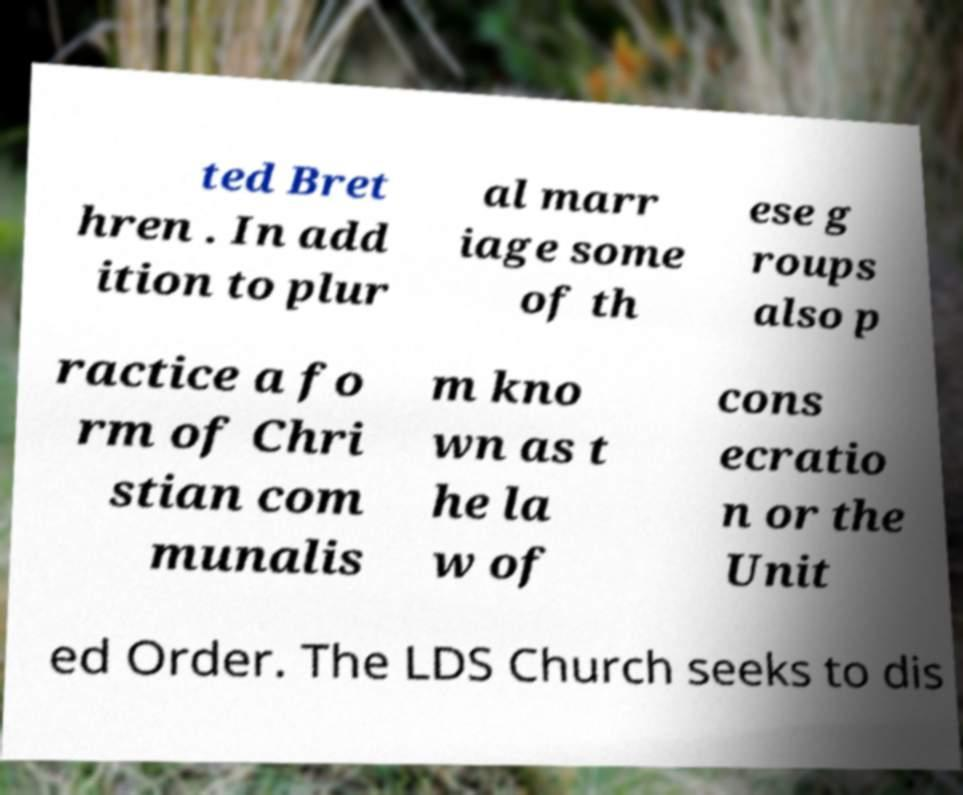Could you extract and type out the text from this image? ted Bret hren . In add ition to plur al marr iage some of th ese g roups also p ractice a fo rm of Chri stian com munalis m kno wn as t he la w of cons ecratio n or the Unit ed Order. The LDS Church seeks to dis 